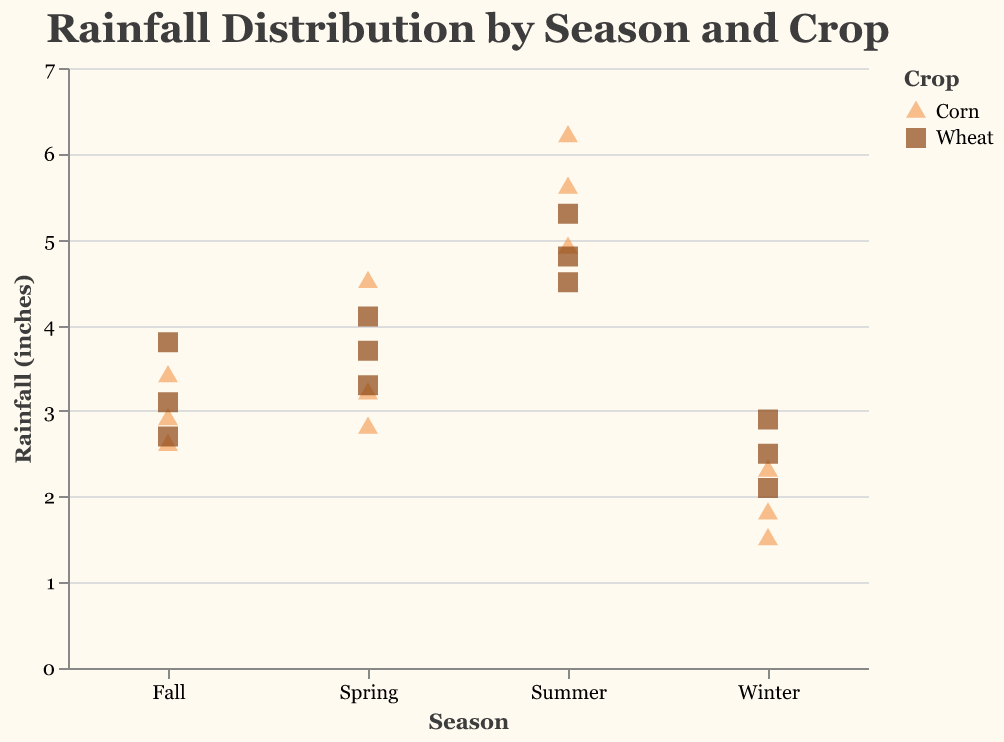How many data points are there for Corn in the Winter season? To find the number of data points for Corn in the Winter season, we look at the strip plot for data points in the Winter section that are colored as Corn. We see three data points for Corn in Winter.
Answer: 3 What is the range of rainfall for Wheat in the Summer? The range can be found by identifying the highest and lowest data points for Wheat in the Summer on the y-axis. The highest rainfall is 5.3 inches and the lowest is 4.5 inches. Therefore, the range is 5.3 - 4.5.
Answer: 0.8 inches Which crop received the highest rainfall in the Summer season? To find the crop with the highest rainfall in Summer, we identify the data point with the maximum y-value in the Summer section. Corn has a data point at 6.2 inches, which is the highest.
Answer: Corn What is the average rainfall for Wheat in the Winter season? To calculate the average rainfall, we sum the rainfall values and divide by the number of data points. The data points for Wheat in Winter are 2.5, 2.9, and 2.1 inches. Summing these gives 7.5, and the average is 7.5/3.
Answer: 2.5 inches Which season has the least variation in rainfall for Corn? We determine the variation by examining the spread of data points for Corn in each season. In Winter, the rainfall varies narrowly from 1.5 to 2.3 inches, indicating the least variation.
Answer: Winter How does the average rainfall for Corn in Summer compare to Spring? Start by calculating the mean rainfall for both seasons. Summer (5.6, 6.2, 4.9) sums to 16.7, and the average is 16.7/3 ≈ 5.57 inches. Spring (3.2, 4.5, 2.8) totals 10.5, so the average is 10.5/3 ≈ 3.5 inches. Compare 5.57 inches (Summer) to 3.5 inches (Spring).
Answer: Higher in Summer than in Spring Which crop has more consistent rainfall throughout the year? We assess consistency by comparing the spread of data points across all seasons for each crop. Wheat has a lower spread of data points and less variability compared to Corn.
Answer: Wheat What can be inferred about the impact of seasonal rainfall on crop growth from the strip plot? Observing the distribution of rainfall data, we see a clear trend: Corn generally requires more rainfall, especially in Summer. Wheat shows stable performance across all seasons with moderate rainfall needs. This suggests optimized growth periods with appropriate rainfall levels for each crop.
Answer: Corn needs more water in Summer; Wheat is more consistent 